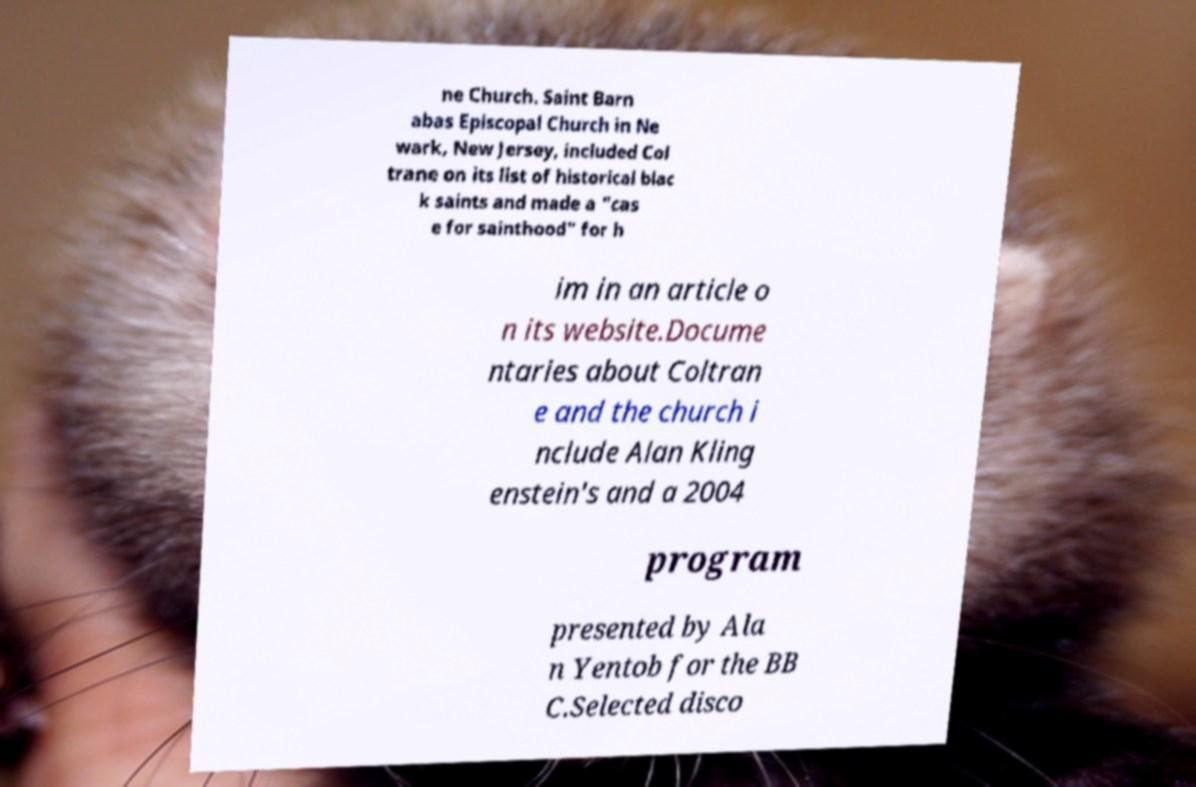For documentation purposes, I need the text within this image transcribed. Could you provide that? ne Church. Saint Barn abas Episcopal Church in Ne wark, New Jersey, included Col trane on its list of historical blac k saints and made a "cas e for sainthood" for h im in an article o n its website.Docume ntaries about Coltran e and the church i nclude Alan Kling enstein's and a 2004 program presented by Ala n Yentob for the BB C.Selected disco 